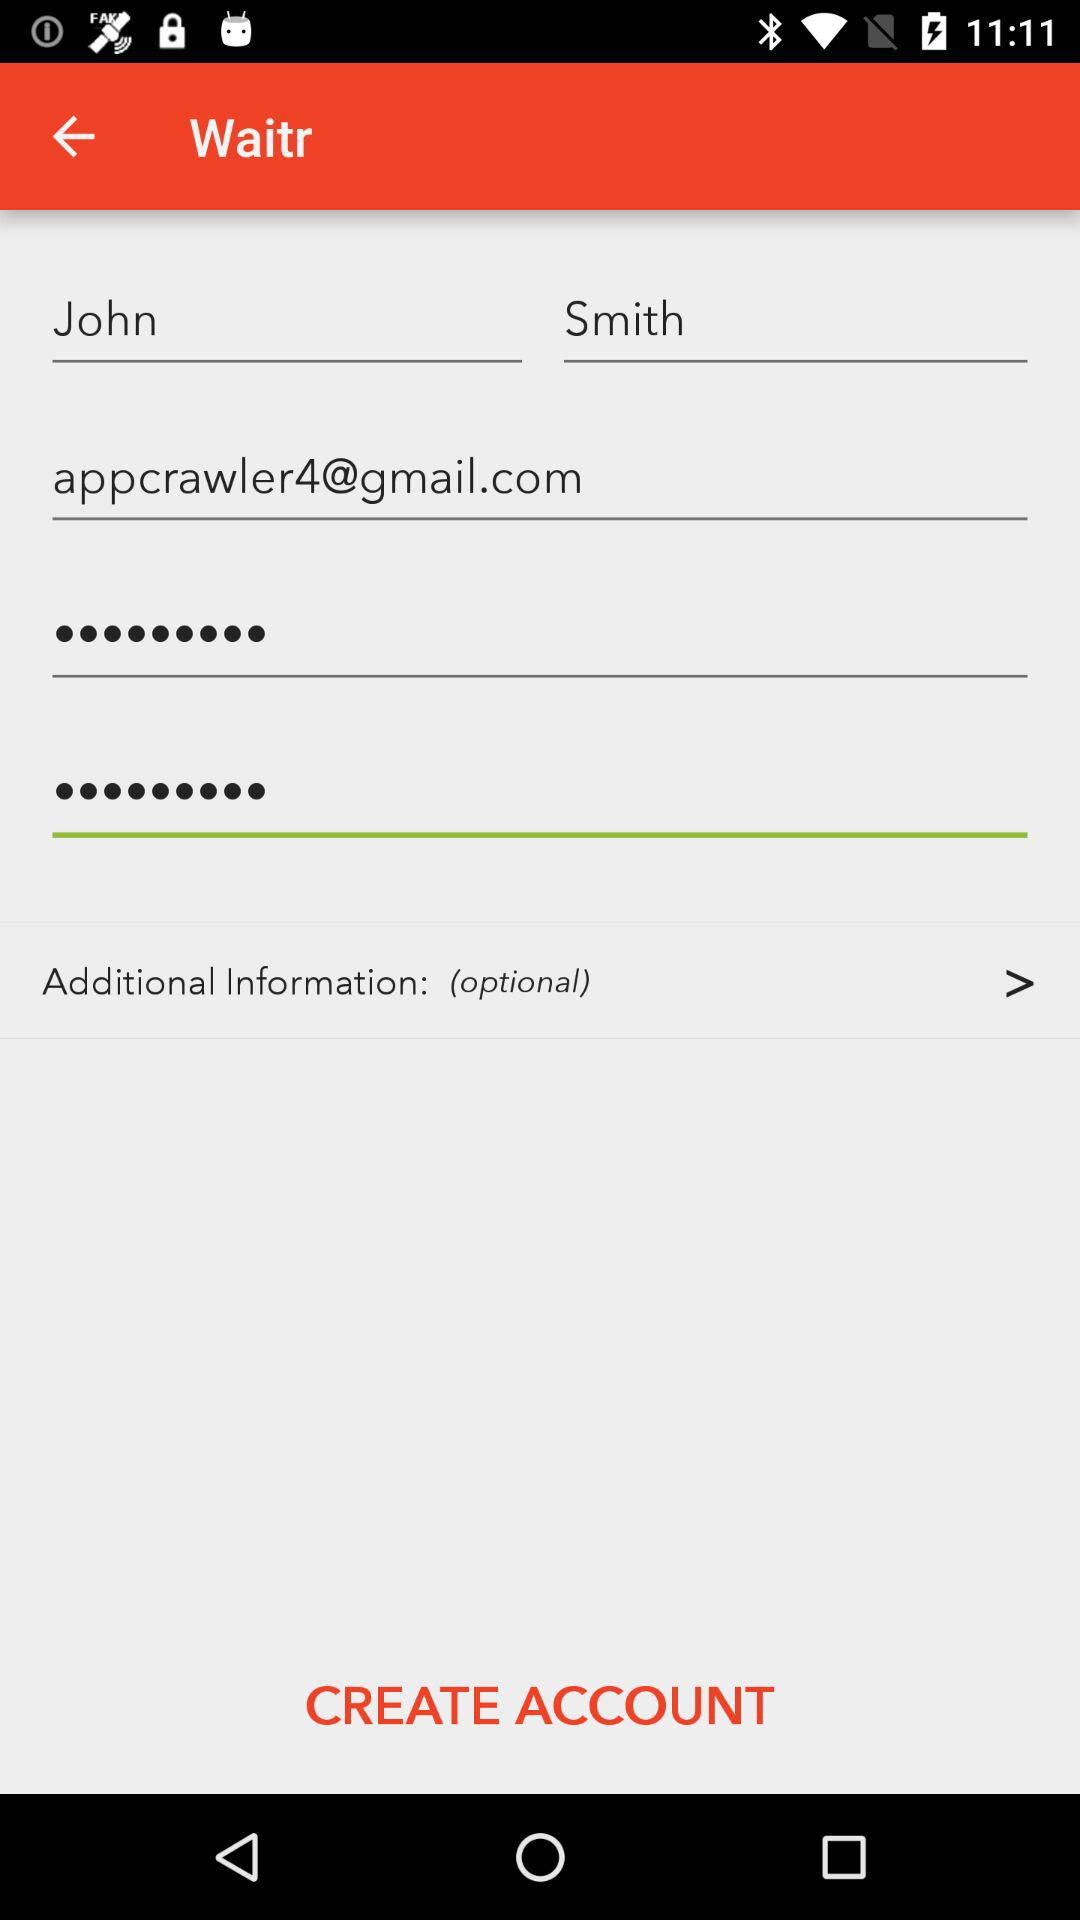What is the email address? The email address is appcrawler4@gmail.com. 